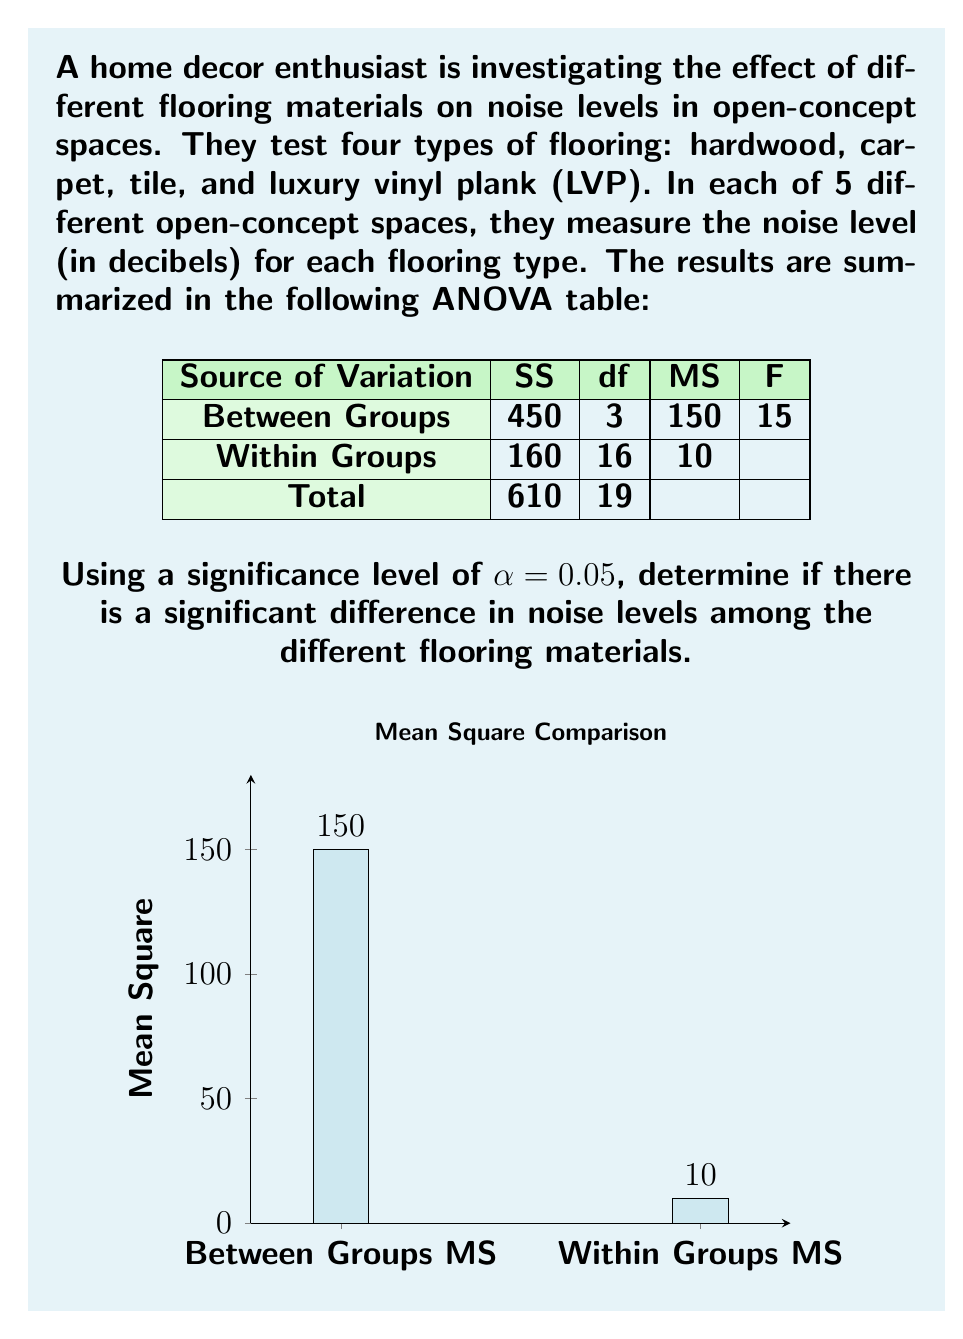Help me with this question. To determine if there is a significant difference in noise levels among the flooring materials, we'll follow these steps:

1) First, identify the test statistic (F-value) from the ANOVA table:
   $F = 15$

2) Determine the degrees of freedom:
   $df_1 = 3$ (between groups)
   $df_2 = 16$ (within groups)

3) Find the critical F-value using an F-distribution table or calculator:
   For $\alpha = 0.05$, $df_1 = 3$, and $df_2 = 16$:
   $F_{critical} = 3.24$ (approximately)

4) Compare the test statistic to the critical value:
   $F = 15 > F_{critical} = 3.24$

5) Calculate the p-value:
   The p-value for $F = 15$ with $df_1 = 3$ and $df_2 = 16$ is approximately $5.32 \times 10^{-5}$, which is much smaller than $\alpha = 0.05$.

6) Make a decision:
   Since $F > F_{critical}$ and $p-value < \alpha$, we reject the null hypothesis.

7) Interpret the result:
   There is strong evidence to suggest that there is a significant difference in noise levels among the different flooring materials in open-concept spaces.
Answer: Reject null hypothesis; significant difference exists (F = 15 > F_critical = 3.24, p < 0.05) 